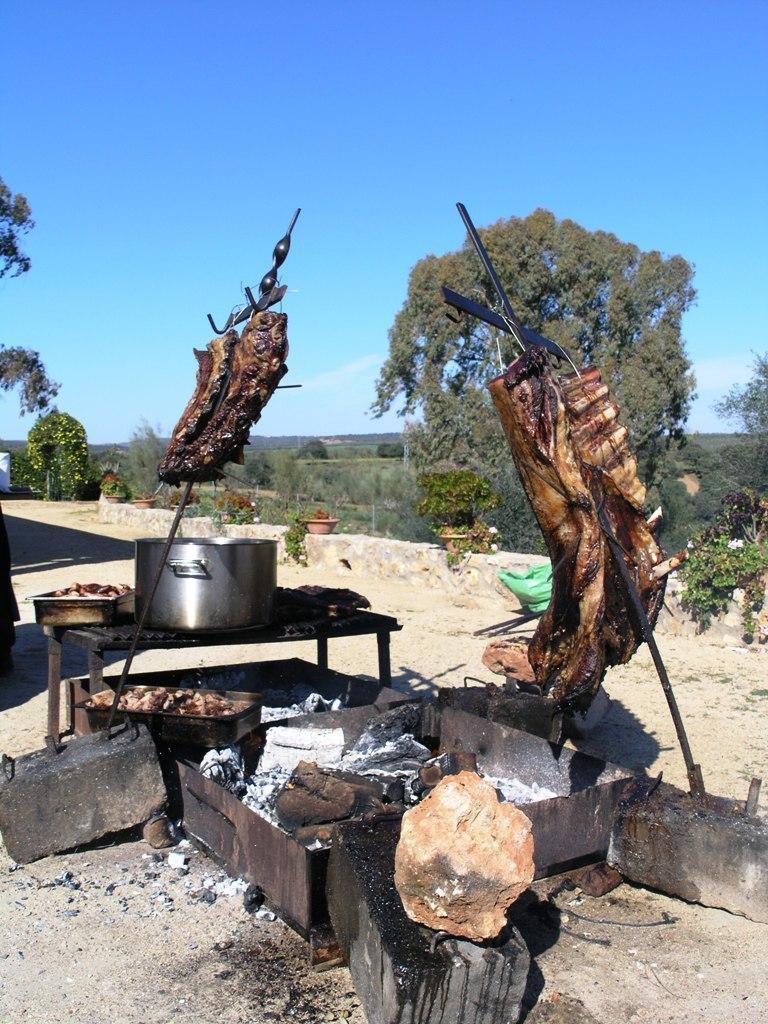Describe this image in one or two sentences. In this image there is a meet cooking on the coal and also there is a pan, beside that there are so many trees. 